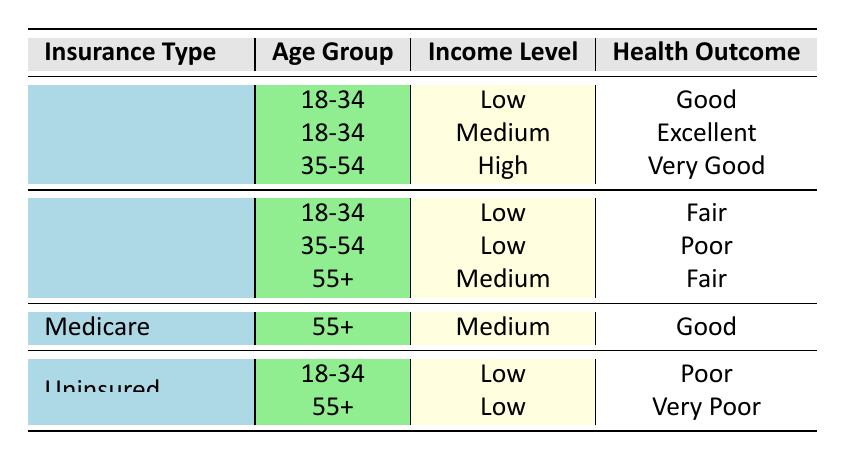What is the health outcome for patients aged 18-34 with Private Insurance and a Low income level? According to the table, for patients aged 18-34 who have Private Insurance and fall under the Low income level, the health outcome is listed as "Good."
Answer: Good How many health outcomes are classified as "Fair" across all insurance types? There are two entries in the table categorized under the health outcome "Fair." The first is for Medicaid in the age group 18-34 with a Low income level, and the second is for Medicaid for those aged 55+ with a Medium income level.
Answer: 2 Is there a health outcome of "Poor" recorded for patients with Medicaid? Yes, the table indicates that there is a health outcome of "Poor" for patients in the 35-54 age group with Medicaid and a Low income level.
Answer: Yes What age group shows the best health outcomes with Private Insurance? Looking at the health outcomes associated with Private Insurance, the 35-54 age group exhibits a health outcome of "Very Good." Considering the other age group of 18-34, which has a "Good" and "Excellent" outcome, "Very Good" is the highest rating.
Answer: 35-54 For patients with Medicaid aged 55+, what is the recorded health outcome and income level? The Medicaid entry for patients aged 55+ shows that the income level is Medium, and the associated health outcome is "Fair." This can be directly observed from the row in the table that describes the 55+ age group under Medicaid.
Answer: Fair, Medium What is the combined health outcome classification for Uninsured patients aged 18-34 and 55+? The Uninsured patients aged 18-34 have a health outcome of "Poor," while those aged 55+ have a health outcome of "Very Poor." To get a total understanding of their classifications, we can identify that both are not favorable outcomes.
Answer: Poor, Very Poor Which insurance type has the worst health outcome for the 55+ age group? Based on the table, the Uninsured patients aged 55+ have a health outcome classified as "Very Poor." In contrast, those with Medicaid have a health outcome of "Fair," and Medicare shows "Good," making Uninsured the worst outcome.
Answer: Uninsured How many insurance types are represented in the table? The table presents four insurance types: Private Insurance, Medicaid, Medicare, and Uninsured. Therefore, by counting distinct entries in the insurance types column, we find that there are four types represented.
Answer: 4 Are there any entries in the table for patients with high income levels across all age groups? Yes, the table shows an entry for Private Insurance in the age group 35-54 with a High income level, indicating that there are patients with high income levels represented in the data.
Answer: Yes 